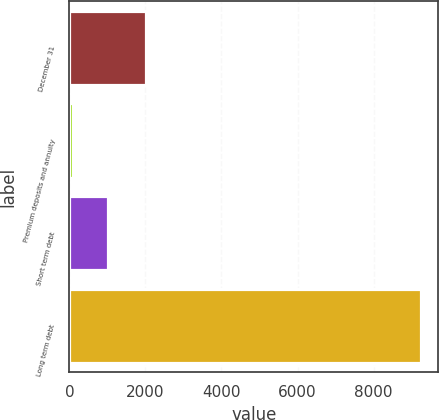<chart> <loc_0><loc_0><loc_500><loc_500><bar_chart><fcel>December 31<fcel>Premium deposits and annuity<fcel>Short term debt<fcel>Long term debt<nl><fcel>2010<fcel>105<fcel>1018.8<fcel>9243<nl></chart> 